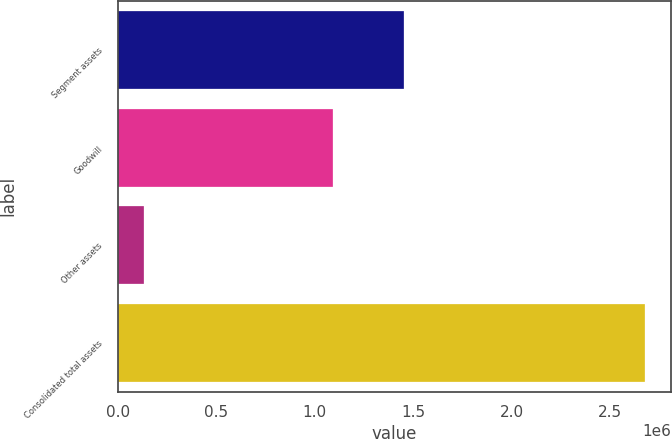<chart> <loc_0><loc_0><loc_500><loc_500><bar_chart><fcel>Segment assets<fcel>Goodwill<fcel>Other assets<fcel>Consolidated total assets<nl><fcel>1.45262e+06<fcel>1.09183e+06<fcel>131283<fcel>2.67573e+06<nl></chart> 